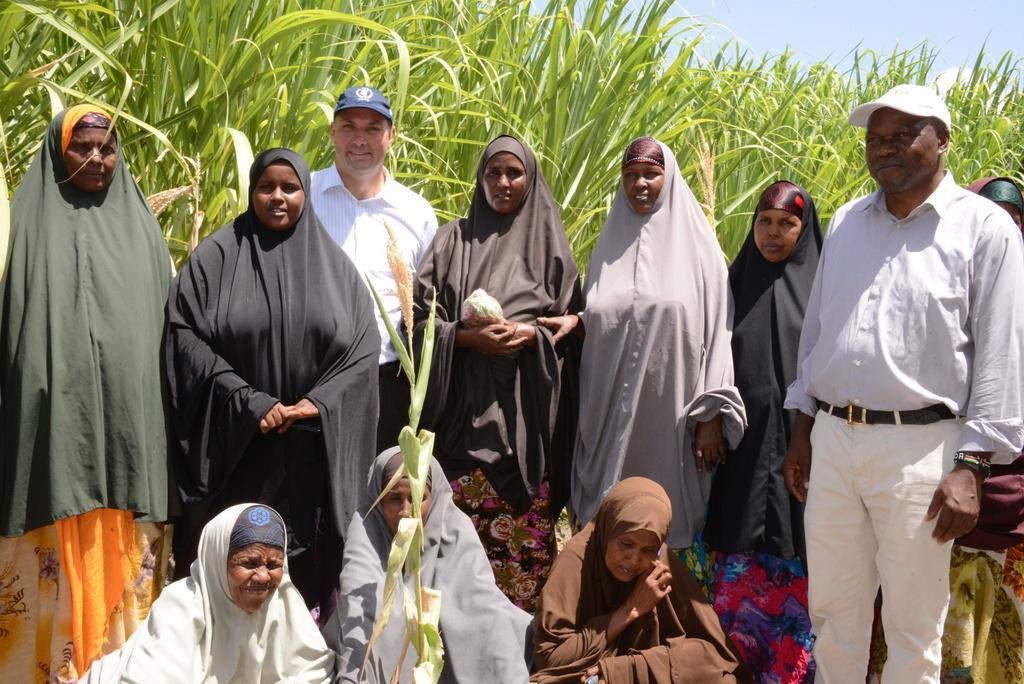How would you summarize this image in a sentence or two? In this image I can see group of people some are sitting and some are standing. Background I can see grass in green color and sky in white color. 